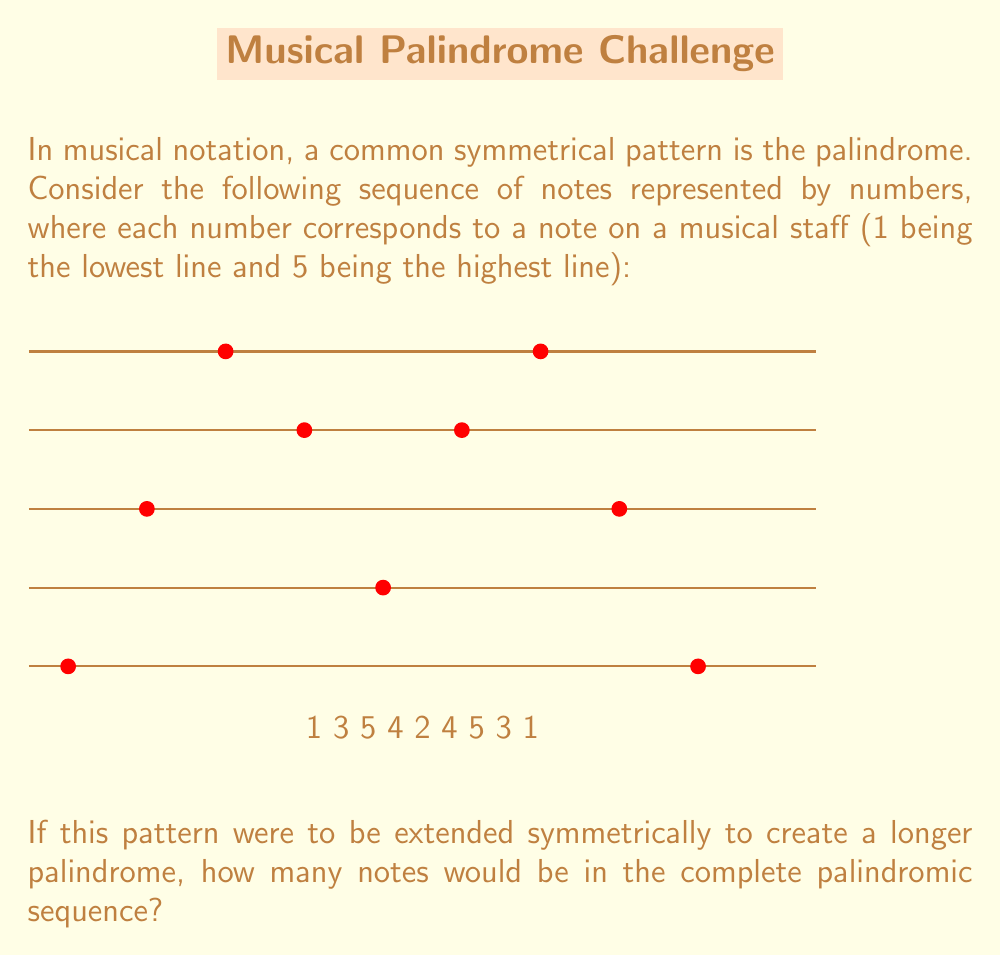Can you solve this math problem? To solve this problem, let's follow these steps:

1) First, we need to understand what a palindrome is in music. It's a sequence that reads the same forwards and backwards.

2) The given sequence is: 1 3 5 4 2 4 5 3 1

3) This sequence is already partially palindromic, as it reads the same from both ends up to the middle '2'.

4) To make it a complete palindrome, we need to mirror the entire sequence, excluding the middle note (2) which acts as the center of symmetry.

5) The sequence without the middle note is: 1 3 5 4 (2) 4 5 3 1

6) To create a full palindrome, we mirror this sequence:
   1 3 5 4 (2) 4 5 3 1 1 3 5 4

7) Now, let's count the notes:
   - The original sequence had 9 notes
   - We removed the middle note (1 note)
   - We added a mirror of the remaining 8 notes

8) So, the total number of notes is:
   $$ 9 - 1 + 8 = 16 $$

Therefore, the complete palindromic sequence would have 16 notes.
Answer: 16 